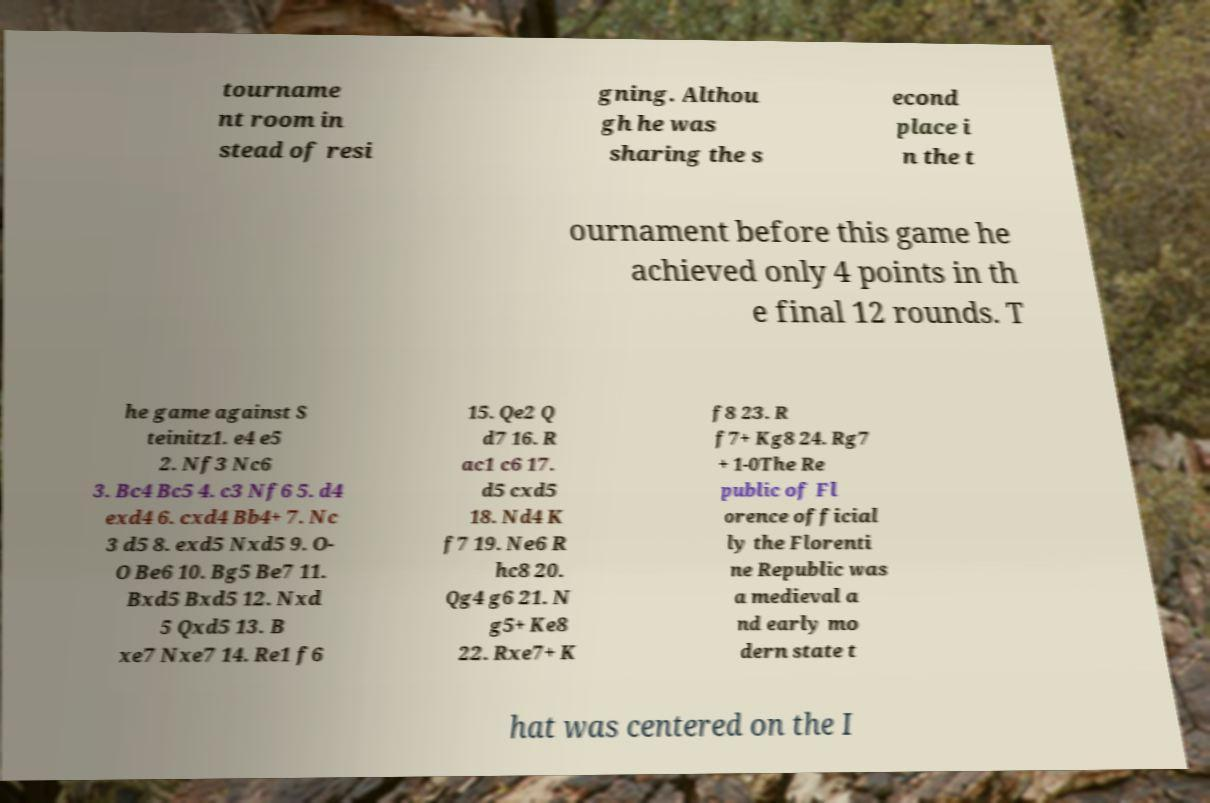Can you accurately transcribe the text from the provided image for me? tourname nt room in stead of resi gning. Althou gh he was sharing the s econd place i n the t ournament before this game he achieved only 4 points in th e final 12 rounds. T he game against S teinitz1. e4 e5 2. Nf3 Nc6 3. Bc4 Bc5 4. c3 Nf6 5. d4 exd4 6. cxd4 Bb4+ 7. Nc 3 d5 8. exd5 Nxd5 9. O- O Be6 10. Bg5 Be7 11. Bxd5 Bxd5 12. Nxd 5 Qxd5 13. B xe7 Nxe7 14. Re1 f6 15. Qe2 Q d7 16. R ac1 c6 17. d5 cxd5 18. Nd4 K f7 19. Ne6 R hc8 20. Qg4 g6 21. N g5+ Ke8 22. Rxe7+ K f8 23. R f7+ Kg8 24. Rg7 + 1-0The Re public of Fl orence official ly the Florenti ne Republic was a medieval a nd early mo dern state t hat was centered on the I 